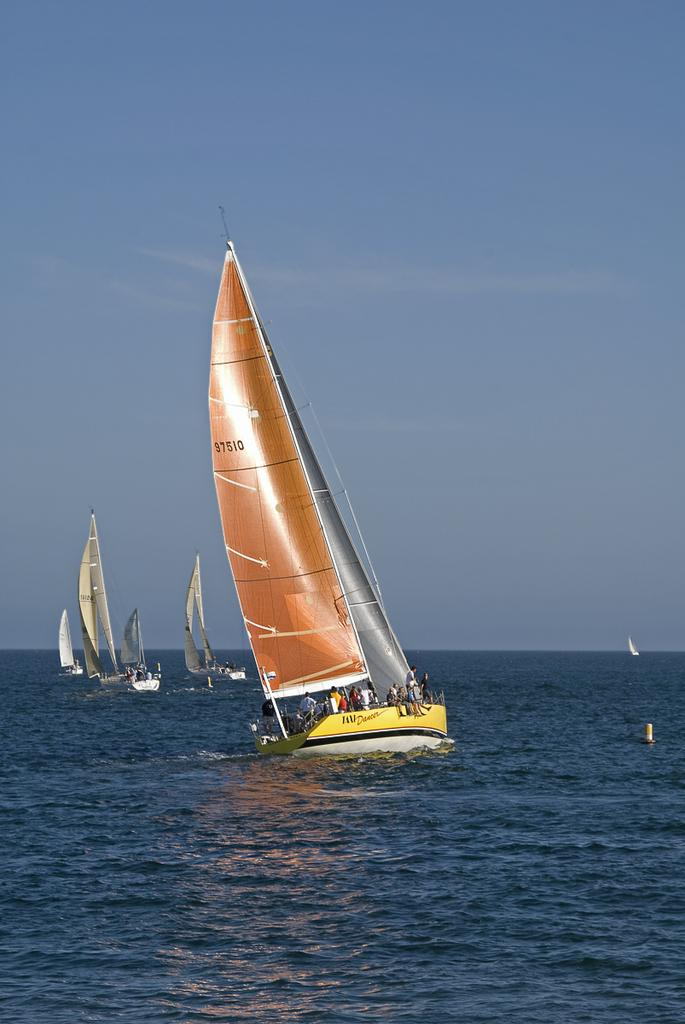What can be seen in the image? There are boats in the image. Where are the boats located? The boats are on the water. Are there any people on the boats? Yes, there are people sitting on the boats. What type of fork can be seen in the image? There is no fork present in the image; it features boats on the water with people sitting on them. 